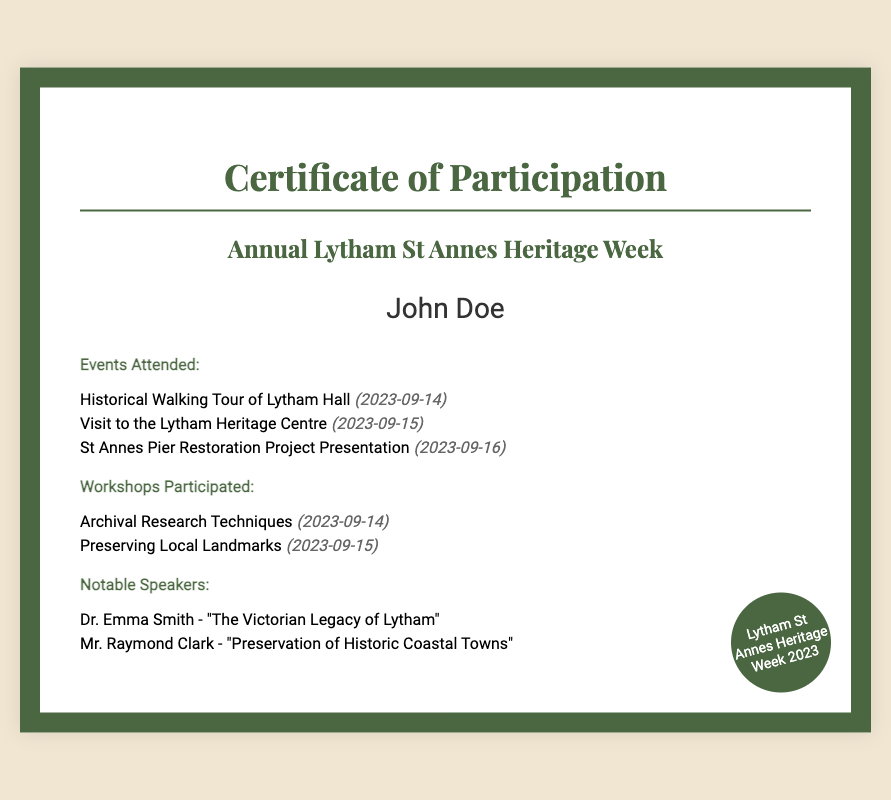What is the title of the certificate? The title of the certificate is at the top of the document, indicating the purpose and event related to the certificate.
Answer: Certificate of Participation Who is the participant named on the certificate? The participant's name is displayed prominently on the certificate, indicating who participated in the events.
Answer: John Doe How many events were attended by the participant? The number of events listed in the document can be counted from the "Events Attended" section.
Answer: 3 What was one of the workshops participated in? The document lists workshops, and this question asks for one example from the "Workshops Participated" section.
Answer: Archival Research Techniques Who was a notable speaker at the event? Notable speakers are mentioned in the document, and this question asks for one of them.
Answer: Dr. Emma Smith When did the Historical Walking Tour of Lytham Hall take place? The date for this event can be found next to the event's name in the "Events Attended" section.
Answer: 2023-09-14 How many workshops are listed in the certificate? The total number of workshops can be determined by counting the items under the "Workshops Participated" section.
Answer: 2 Which event was held on September 16, 2023? The events include specific dates, where connections can be made between the date and the respective event's name.
Answer: St Annes Pier Restoration Project Presentation What is the theme of Dr. Emma Smith's presentation? The title of the presentation given by Dr. Emma Smith is listed among the notable speakers information.
Answer: The Victorian Legacy of Lytham 